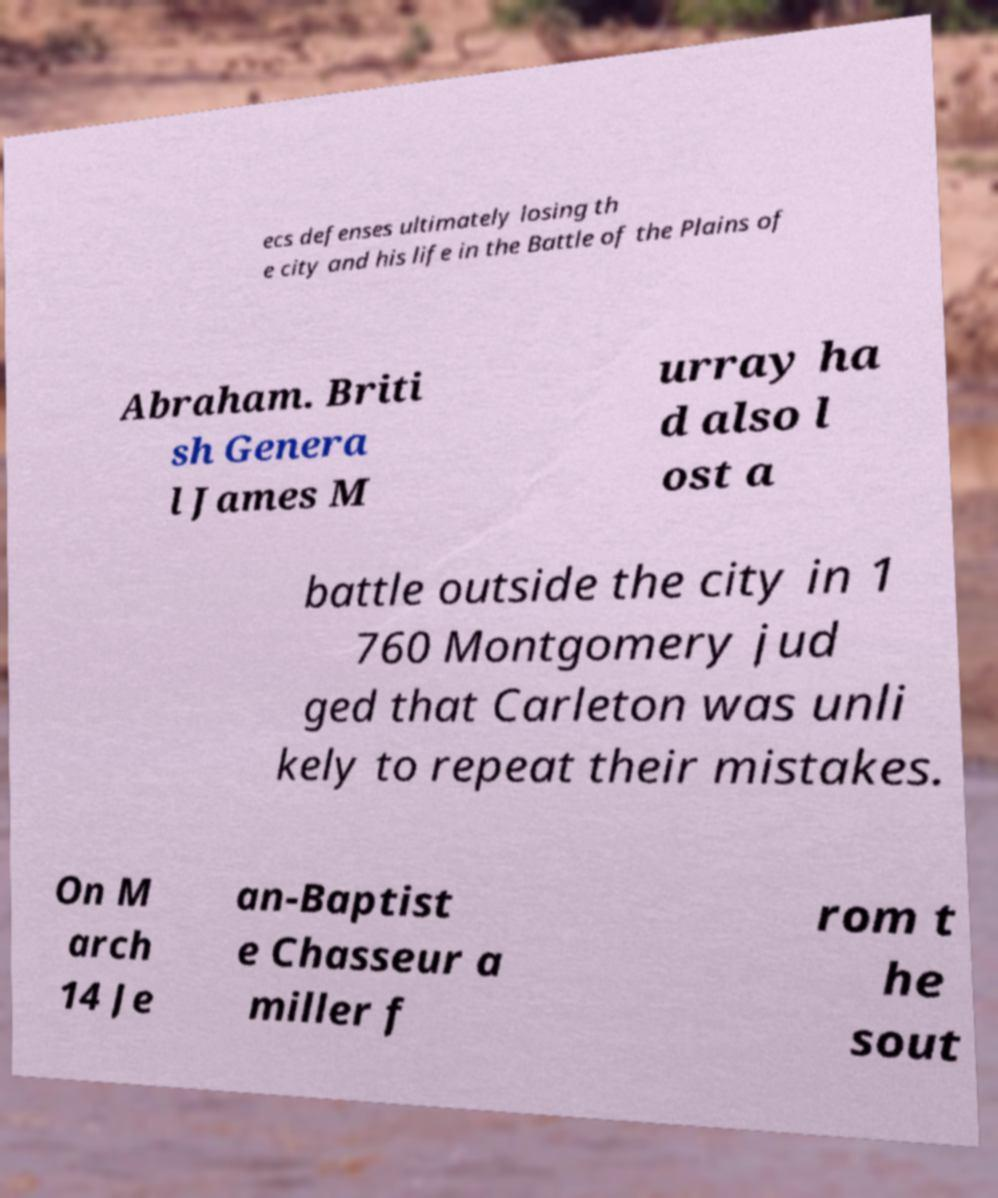Please read and relay the text visible in this image. What does it say? ecs defenses ultimately losing th e city and his life in the Battle of the Plains of Abraham. Briti sh Genera l James M urray ha d also l ost a battle outside the city in 1 760 Montgomery jud ged that Carleton was unli kely to repeat their mistakes. On M arch 14 Je an-Baptist e Chasseur a miller f rom t he sout 